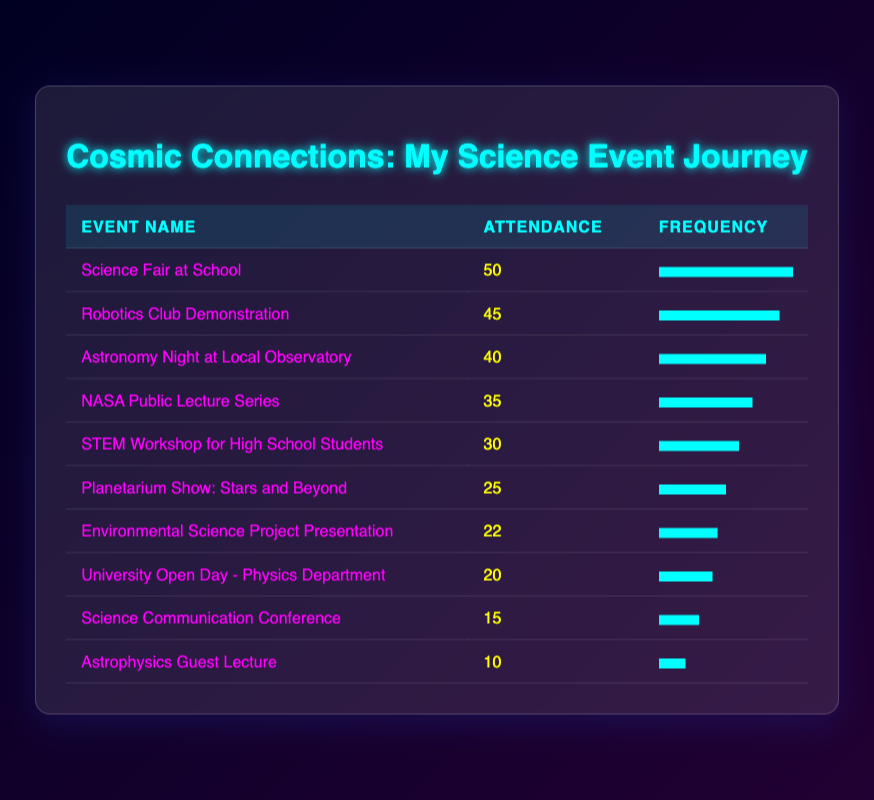What is the highest attendance recorded at any event? By scanning the attendance figures in the table, the highest number is 50 from the "Science Fair at School."
Answer: 50 Which event had the lowest attendance? Looking through the table, the event with the lowest attendance is the "Astrophysics Guest Lecture" with an attendance of 10.
Answer: 10 How many events had an attendance of 30 or more? Counting the events listed with attendance of 30 or higher: "Science Fair at School" (50), "Robotics Club Demonstration" (45), "Astronomy Night at Local Observatory" (40), "NASA Public Lecture Series" (35) and "STEM Workshop" (30), we find a total of 5 events.
Answer: 5 What is the average attendance across all events? To find the average, sum the attendance numbers: 35 + 40 + 50 + 20 + 30 + 25 + 15 + 10 + 45 + 22 = 292. There are 10 events, so divide: 292/10 = 29.2.
Answer: 29.2 Is there more than one event that had an attendance of 20 or less? Reviewing the attendance numbers, there are only two events that fall below or equal to 20: "Science Communication Conference" (15) and "Astrophysics Guest Lecture" (10), confirming that yes, there are two such events.
Answer: Yes What is the difference in attendance between the event with the highest and the event with the lowest attendance? The highest attendance is 50 from "Science Fair at School," and the lowest is 10 from "Astrophysics Guest Lecture." The difference is 50 - 10 = 40.
Answer: 40 If we exclude the top three attended events, what is the new average of the remaining events? Excluding the top three events: "Science Fair at School" (50), "Robotics Club Demonstration" (45), and "Astronomy Night" (40), the remaining attendances are 35, 30, 25, 22, 20, 15, and 10. Their sum is 35 + 30 + 25 + 22 + 20 + 15 + 10 = 157. There are 7 events, so the new average is 157/7 = 22.43.
Answer: 22.43 